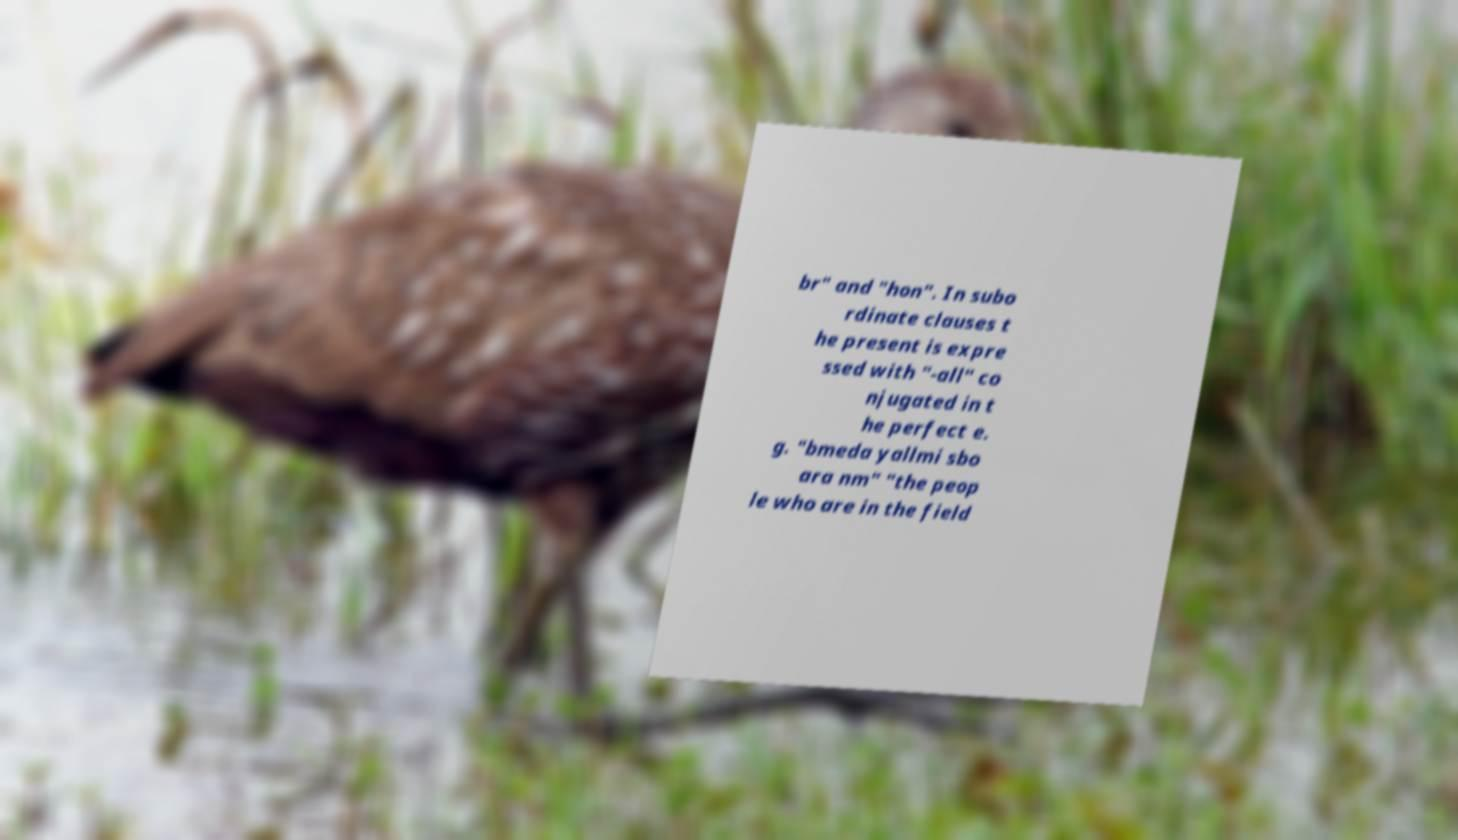Could you assist in decoding the text presented in this image and type it out clearly? br" and "hon". In subo rdinate clauses t he present is expre ssed with "-all" co njugated in t he perfect e. g. "bmeda yallmi sbo ara nm" "the peop le who are in the field 